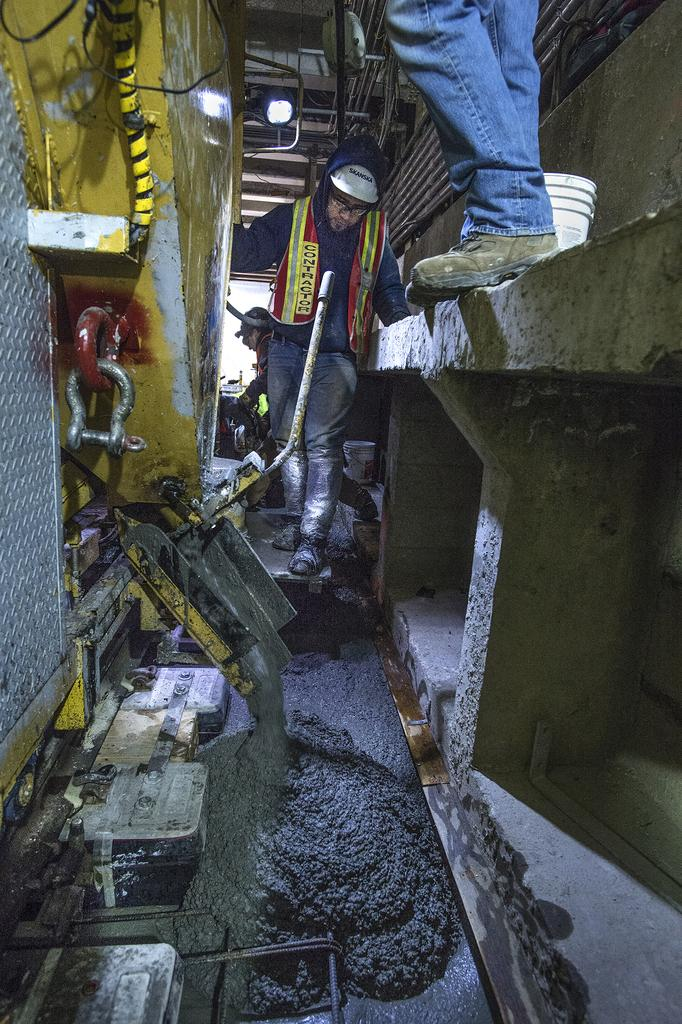What can be seen in the image regarding people? There are men standing in the image. What type of equipment is present in the image? There is a machine in the image. What container is visible in the image? There is a bucket in the image. Can you describe the lighting in the image? There is a light attached to the ceiling in the image. What substance is on the floor in the image? There is concrete mixture on the floor in the image. What type of skirt is the machine wearing in the image? The machine is not wearing a skirt, as it is an inanimate object and does not have clothing. 